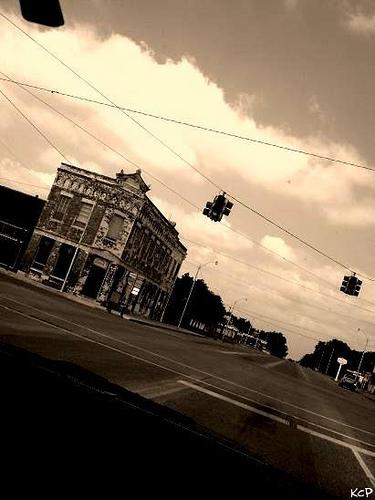Has it just snowed?
Short answer required. No. What color is the sky?
Concise answer only. Gray. Is this picture slanted?
Write a very short answer. Yes. What is suspended from the wires?
Be succinct. Traffic lights. Is this flat terrain?
Be succinct. Yes. Is this photo taken in the summer?
Short answer required. No. What is the structure in the background?
Be succinct. Building. Do you see any mountains?
Concise answer only. No. Is it summer?
Concise answer only. No. 